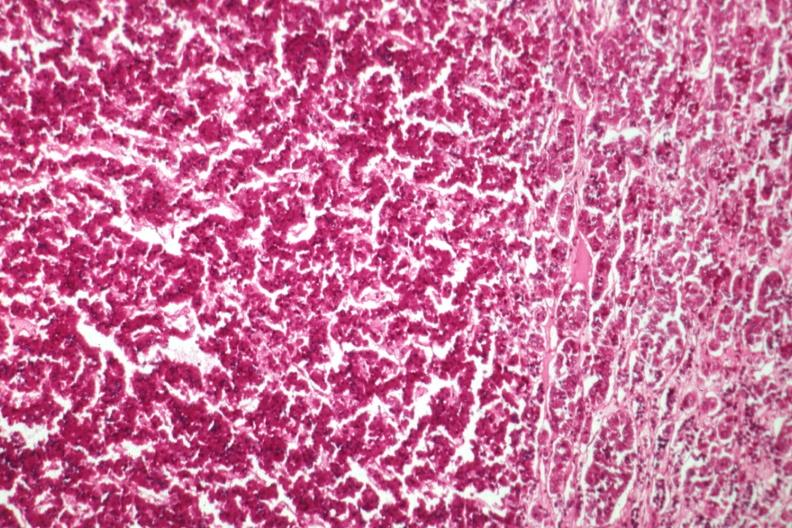s eosinophilic adenoma present?
Answer the question using a single word or phrase. Yes 